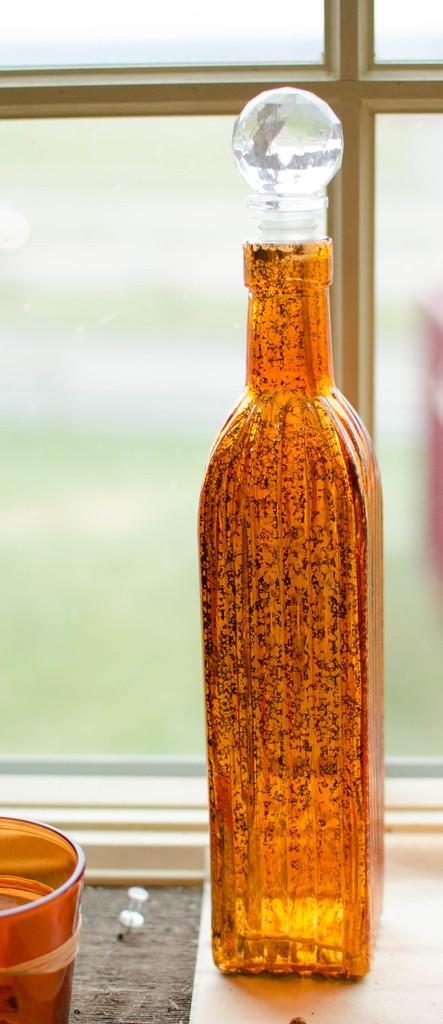What object can be seen in the image that is used for holding liquids? There is a bottle in the image that is used for holding liquids. What color is the bottle in the image? The bottle is yellow. What other object in the image is also yellow and used for holding liquids? There is a glass in the image that is also yellow and used for holding liquids. What can be seen in the background of the image? There is a glass window in the background of the image. What type of knot is being tied by the glass in the image? There is no knot being tied by the glass in the image, as it is an inanimate object used for holding liquids. 